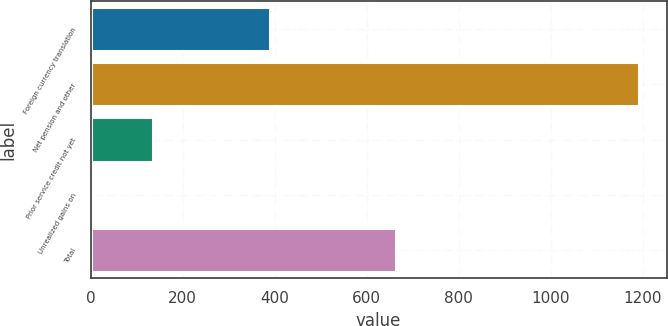Convert chart. <chart><loc_0><loc_0><loc_500><loc_500><bar_chart><fcel>Foreign currency translation<fcel>Net pension and other<fcel>Prior service credit not yet<fcel>Unrealized gains on<fcel>Total<nl><fcel>389<fcel>1192<fcel>136<fcel>3<fcel>664<nl></chart> 